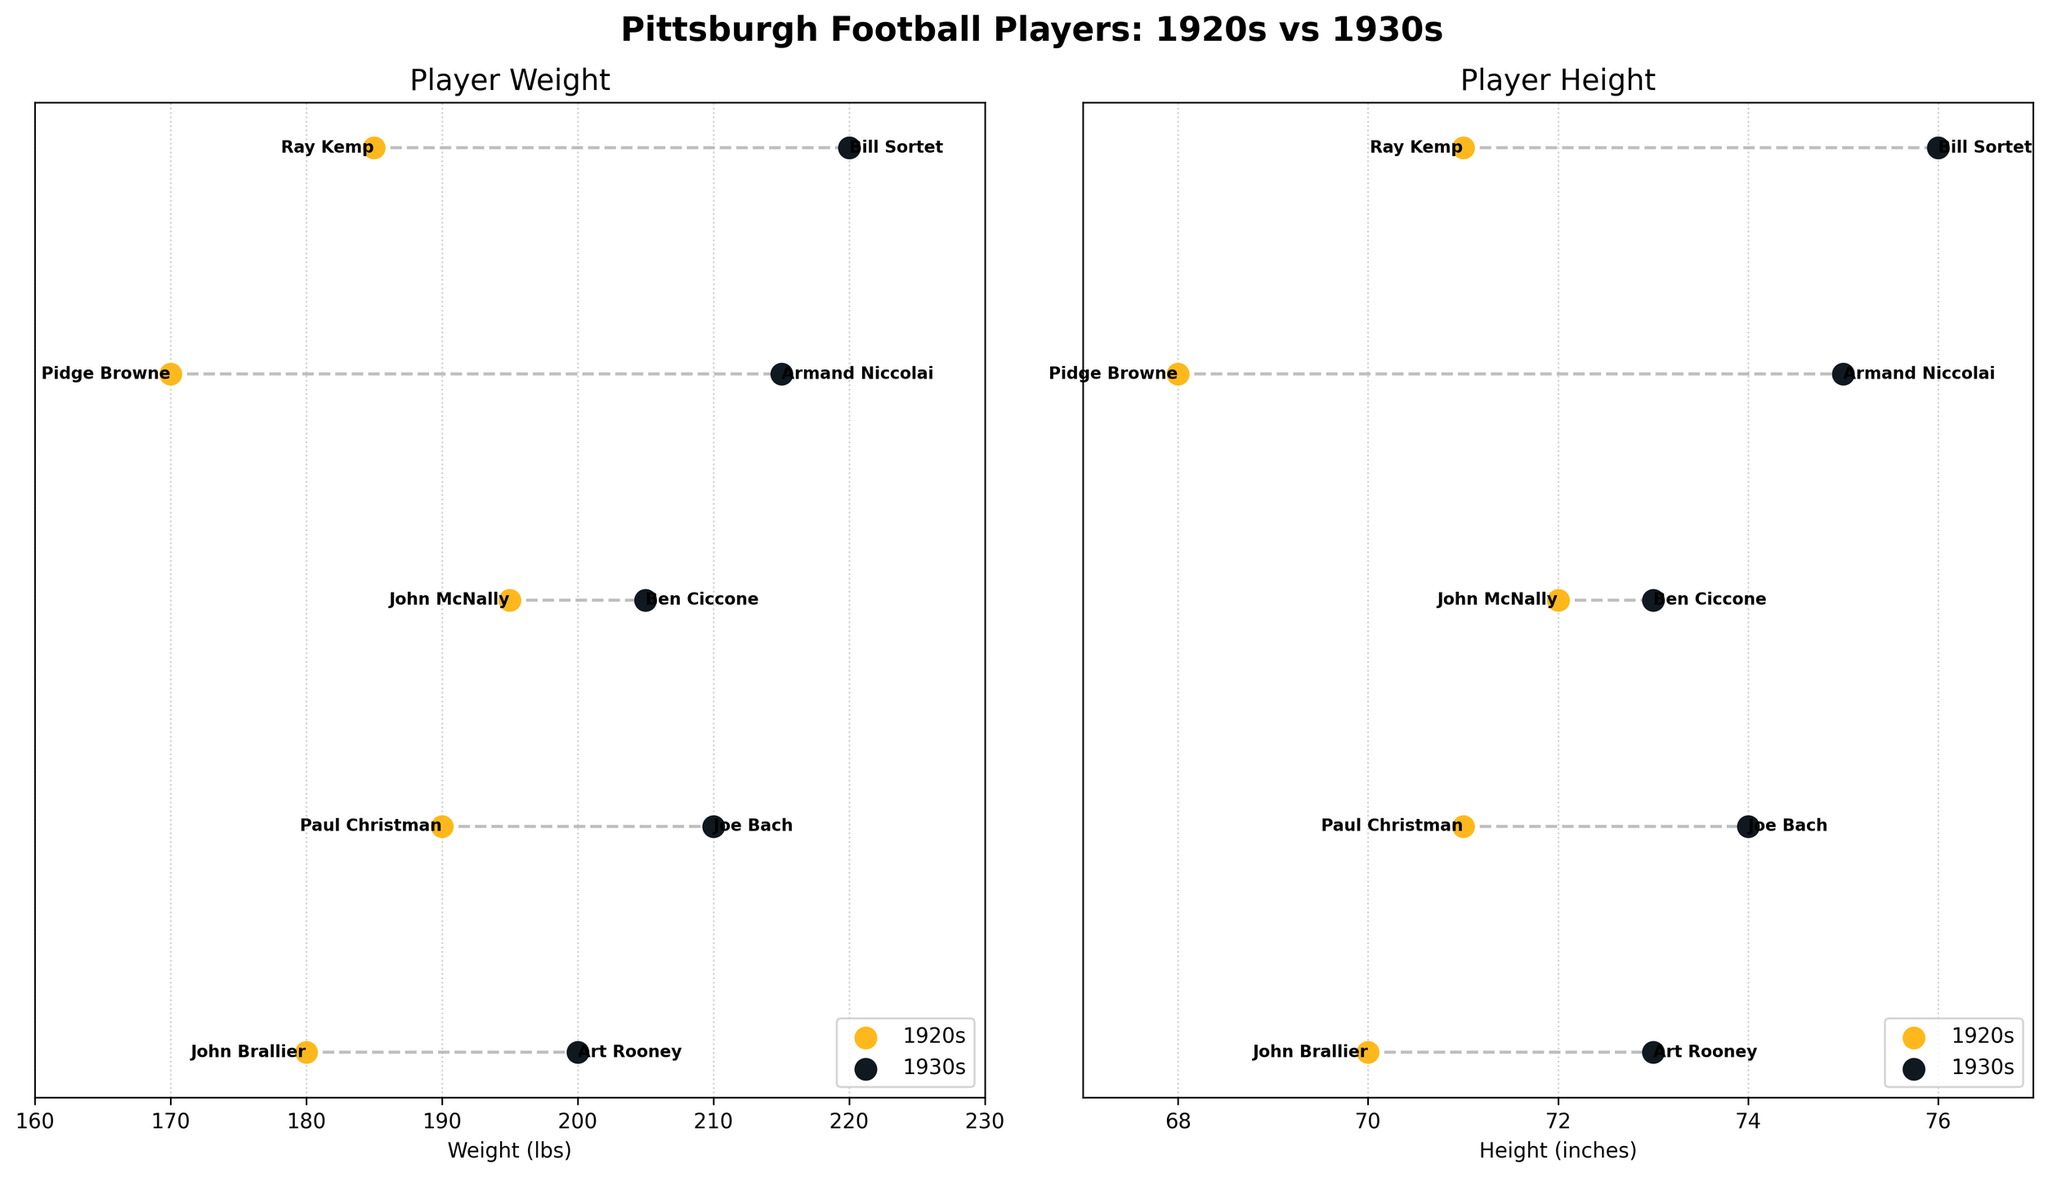What is the title of the figure? The title is prominently displayed at the top of the figure and provides a summary of the comparison being made.
Answer: Pittsburgh Football Players: 1920s vs 1930s How many players are listed from the 1920s? By counting the text labels representing players under the 1920s section in either subplot, you can identify the number of players.
Answer: 4 Which era has players with greater average height? Calculate the average height for each era by summing the heights of players within each era and dividing by the number of players. The comparison will reveal which era has a higher average.
Answer: 1930s What's the difference in weight between the heaviest player and the lightest player? Identify the heaviest player by finding the maximum weight and the lightest player by finding the minimum weight. Subtract the minimum weight from the maximum weight.
Answer: 50 lbs Who is the heaviest player in the 1930s era? Locate the highest point on the weight axis for the 1930s era subplot and refer to the corresponding player label.
Answer: Bill Sortet Are there more players listed in the 1920s or 1930s? Count the number of players listed in each era and compare the totals.
Answer: 1930s Does the height variability appear greater in the 1920s or 1930s? Assess the range (difference between the maximum and minimum values) and the spread of the height points plotted for each era.
Answer: 1930s What is the average weight of players from the 1920s era? Sum the weights of all the players listed in the 1920s and divide by the number of players. (180+190+195+185)/4 = 750/4 = 187.5
Answer: 187.5 lbs How does Art Rooney's height compare to other players from the 1930s? Identify Art Rooney's height and compare it to the heights of other players listed in the 1930s. He is in the middle range compared to others in his era.
Answer: Middle range What is the overall trend in player weights from the 1920s to the 1930s? Compare the weight distribution and averages for each era, noting whether players in the 1930s are generally heavier or lighter than those in the 1920s.
Answer: Increase in weight 